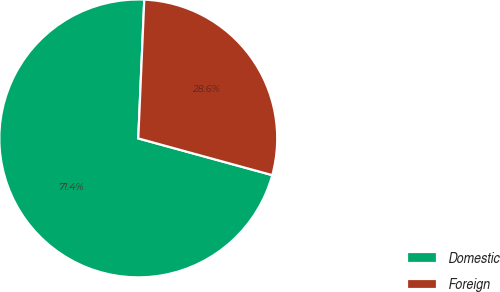Convert chart. <chart><loc_0><loc_0><loc_500><loc_500><pie_chart><fcel>Domestic<fcel>Foreign<nl><fcel>71.43%<fcel>28.57%<nl></chart> 